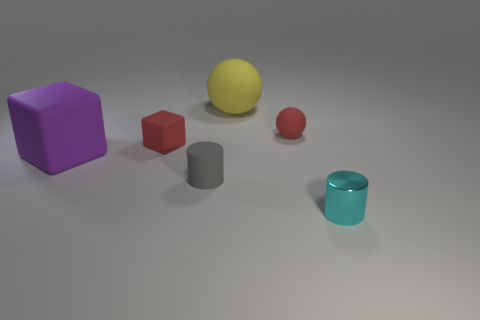Add 4 blue metal blocks. How many objects exist? 10 Subtract all cylinders. How many objects are left? 4 Add 6 small green matte cylinders. How many small green matte cylinders exist? 6 Subtract 0 yellow blocks. How many objects are left? 6 Subtract all yellow balls. Subtract all tiny matte cylinders. How many objects are left? 4 Add 4 red matte blocks. How many red matte blocks are left? 5 